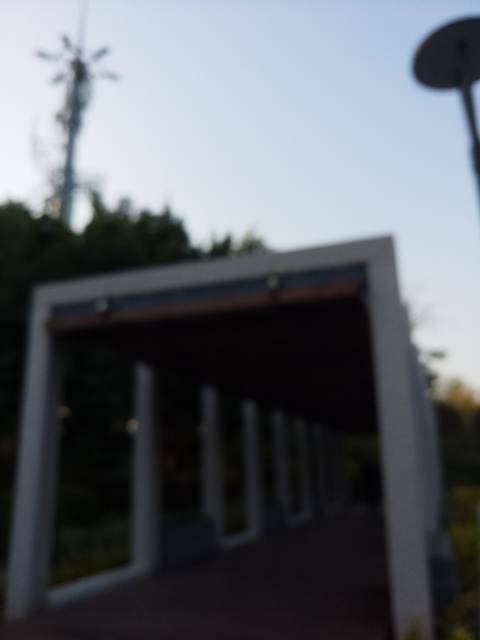What is the composition of the image?
A. Poor
B. Balanced
C. Harmonious Without a clear focus and considering the image is out of focus, it's challenging to define the composition as balanced or harmonious. Therefore, the composition could be deemed as less than ideal, or 'Poor', when strictly evaluating the technical aspect of the visual presentation. 